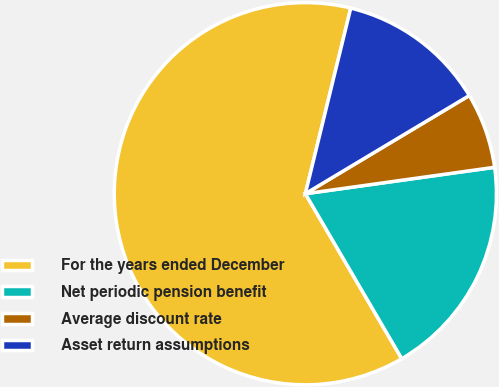Convert chart. <chart><loc_0><loc_0><loc_500><loc_500><pie_chart><fcel>For the years ended December<fcel>Net periodic pension benefit<fcel>Average discount rate<fcel>Asset return assumptions<nl><fcel>62.23%<fcel>18.79%<fcel>6.38%<fcel>12.59%<nl></chart> 